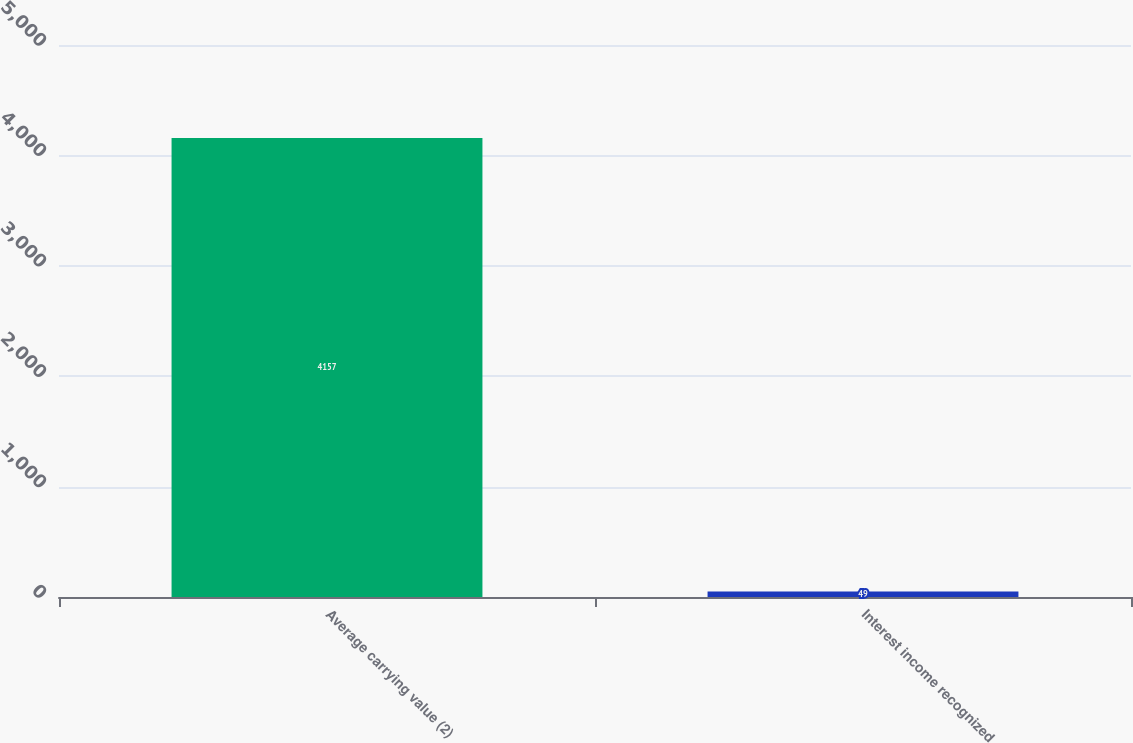Convert chart. <chart><loc_0><loc_0><loc_500><loc_500><bar_chart><fcel>Average carrying value (2)<fcel>Interest income recognized<nl><fcel>4157<fcel>49<nl></chart> 